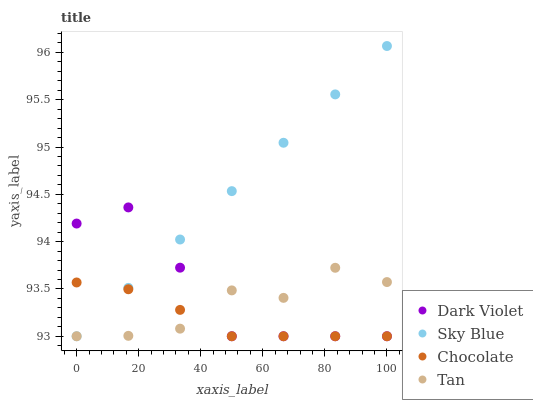Does Chocolate have the minimum area under the curve?
Answer yes or no. Yes. Does Sky Blue have the maximum area under the curve?
Answer yes or no. Yes. Does Tan have the minimum area under the curve?
Answer yes or no. No. Does Tan have the maximum area under the curve?
Answer yes or no. No. Is Sky Blue the smoothest?
Answer yes or no. Yes. Is Tan the roughest?
Answer yes or no. Yes. Is Dark Violet the smoothest?
Answer yes or no. No. Is Dark Violet the roughest?
Answer yes or no. No. Does Sky Blue have the lowest value?
Answer yes or no. Yes. Does Sky Blue have the highest value?
Answer yes or no. Yes. Does Tan have the highest value?
Answer yes or no. No. Does Chocolate intersect Sky Blue?
Answer yes or no. Yes. Is Chocolate less than Sky Blue?
Answer yes or no. No. Is Chocolate greater than Sky Blue?
Answer yes or no. No. 